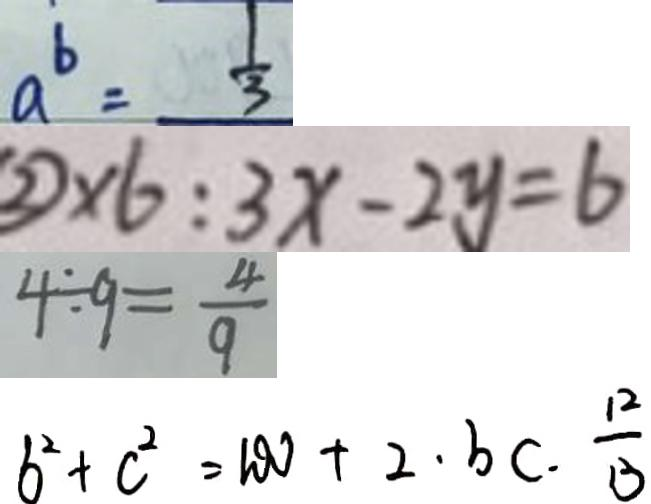Convert formula to latex. <formula><loc_0><loc_0><loc_500><loc_500>a ^ { b } = \frac { 1 } { 3 } 
 \textcircled { 2 } \times 6 : 3 x - 2 y = 6 
 4 \div 9 = \frac { 4 } { 9 } 
 b ^ { 2 } + c ^ { 2 } = 1 0 0 + 2 \cdot b c \cdot \frac { 1 2 } { 3 }</formula> 